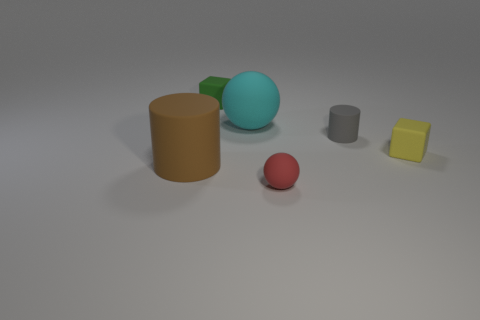Add 4 big brown matte cylinders. How many objects exist? 10 Subtract all blocks. How many objects are left? 4 Add 3 brown cylinders. How many brown cylinders exist? 4 Subtract 0 yellow spheres. How many objects are left? 6 Subtract all big cyan matte things. Subtract all tiny gray rubber cylinders. How many objects are left? 4 Add 4 brown rubber cylinders. How many brown rubber cylinders are left? 5 